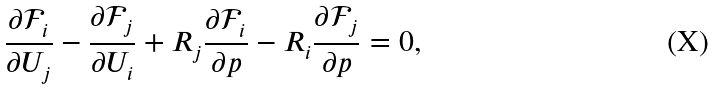Convert formula to latex. <formula><loc_0><loc_0><loc_500><loc_500>\frac { \partial \mathcal { F } _ { i } } { \partial U _ { j } } - \frac { \partial \mathcal { F } _ { j } } { \partial U _ { i } } + R _ { j } \frac { \partial \mathcal { F } _ { i } } { \partial p } - R _ { i } \frac { \partial \mathcal { F } _ { j } } { \partial p } = 0 ,</formula> 